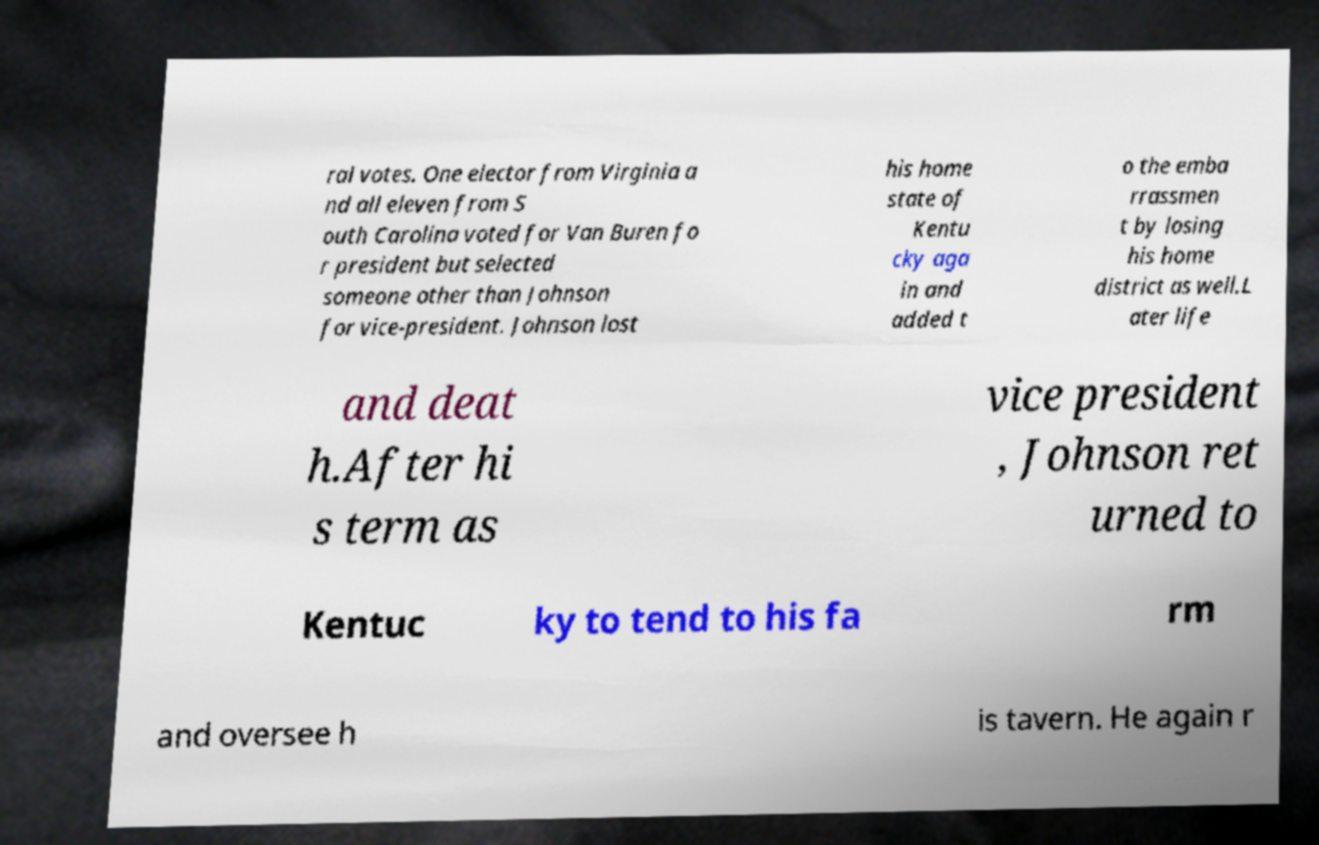There's text embedded in this image that I need extracted. Can you transcribe it verbatim? ral votes. One elector from Virginia a nd all eleven from S outh Carolina voted for Van Buren fo r president but selected someone other than Johnson for vice-president. Johnson lost his home state of Kentu cky aga in and added t o the emba rrassmen t by losing his home district as well.L ater life and deat h.After hi s term as vice president , Johnson ret urned to Kentuc ky to tend to his fa rm and oversee h is tavern. He again r 